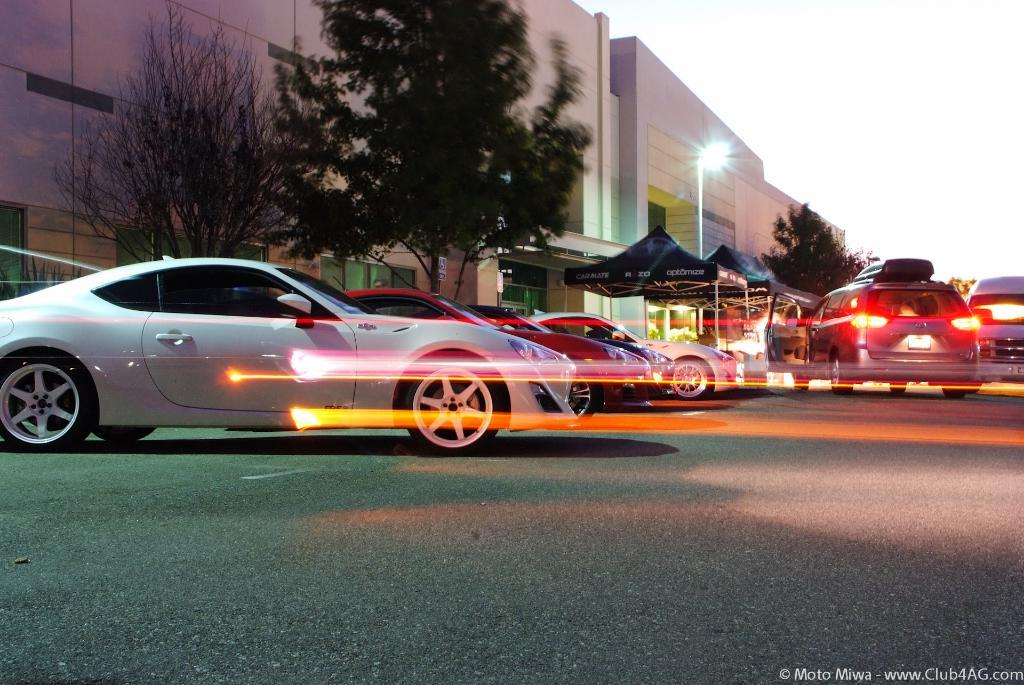What can be seen on the road in the image? There are vehicles on the road in the image. What structures are visible in the image? There are buildings in the image. What type of vegetation is present in the image? Trees are present in the image. What type of street furniture can be seen in the image? There is a light pole in the image. What additional objects are present in the image? There are black color tents in front of the scene. What is the color of the sky in the image? The sky appears to be white in color. What type of cattle can be seen grazing in the image? There are no cattle present in the image. What does the image smell like? The image does not have a smell, as it is a visual representation. How many fingers can be seen pointing at the light pole in the image? There are no fingers visible in the image. 